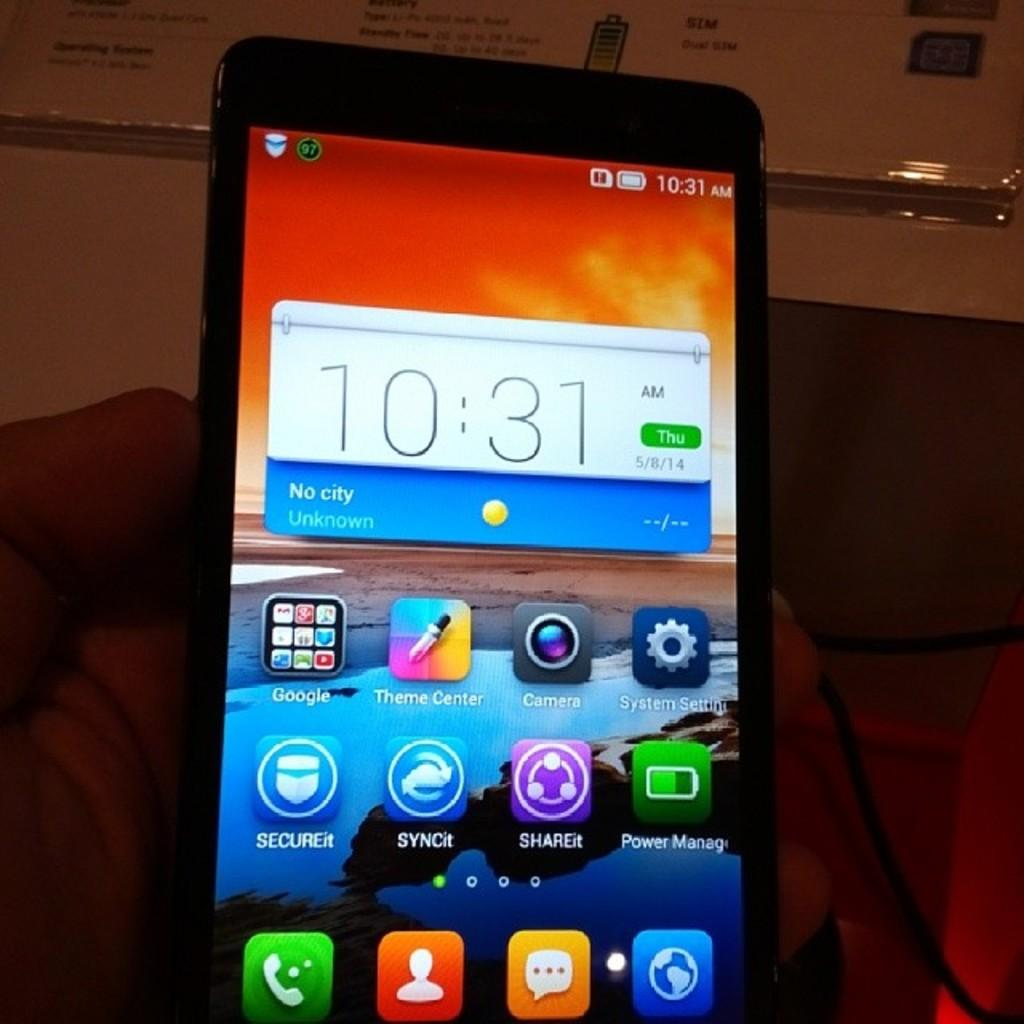Provide a one-sentence caption for the provided image. cellphone showing 10:31 am with date of thurs 5/8/14. 